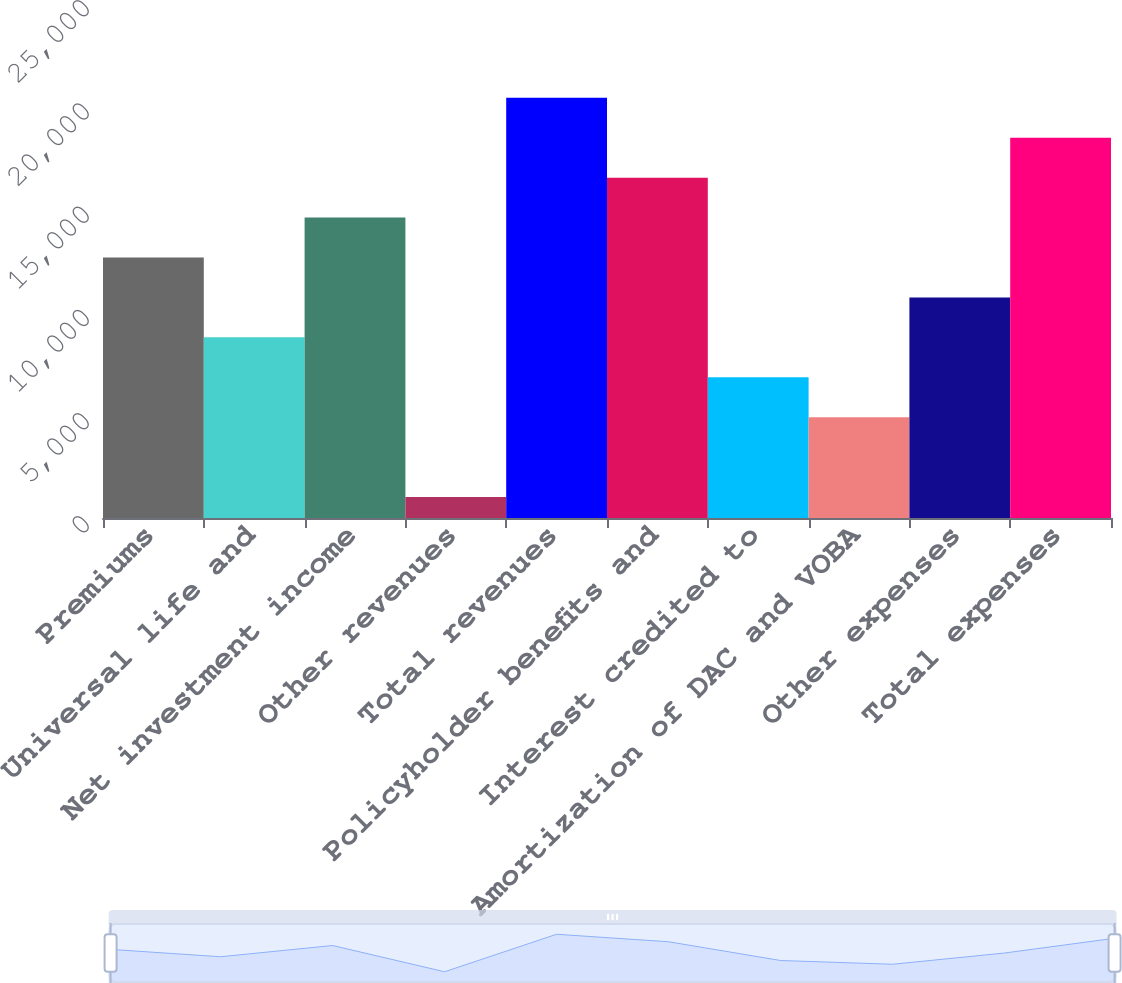Convert chart to OTSL. <chart><loc_0><loc_0><loc_500><loc_500><bar_chart><fcel>Premiums<fcel>Universal life and<fcel>Net investment income<fcel>Other revenues<fcel>Total revenues<fcel>Policyholder benefits and<fcel>Interest credited to<fcel>Amortization of DAC and VOBA<fcel>Other expenses<fcel>Total expenses<nl><fcel>12620.8<fcel>8753.2<fcel>14554.6<fcel>1018<fcel>20356<fcel>16488.4<fcel>6819.4<fcel>4885.6<fcel>10687<fcel>18422.2<nl></chart> 